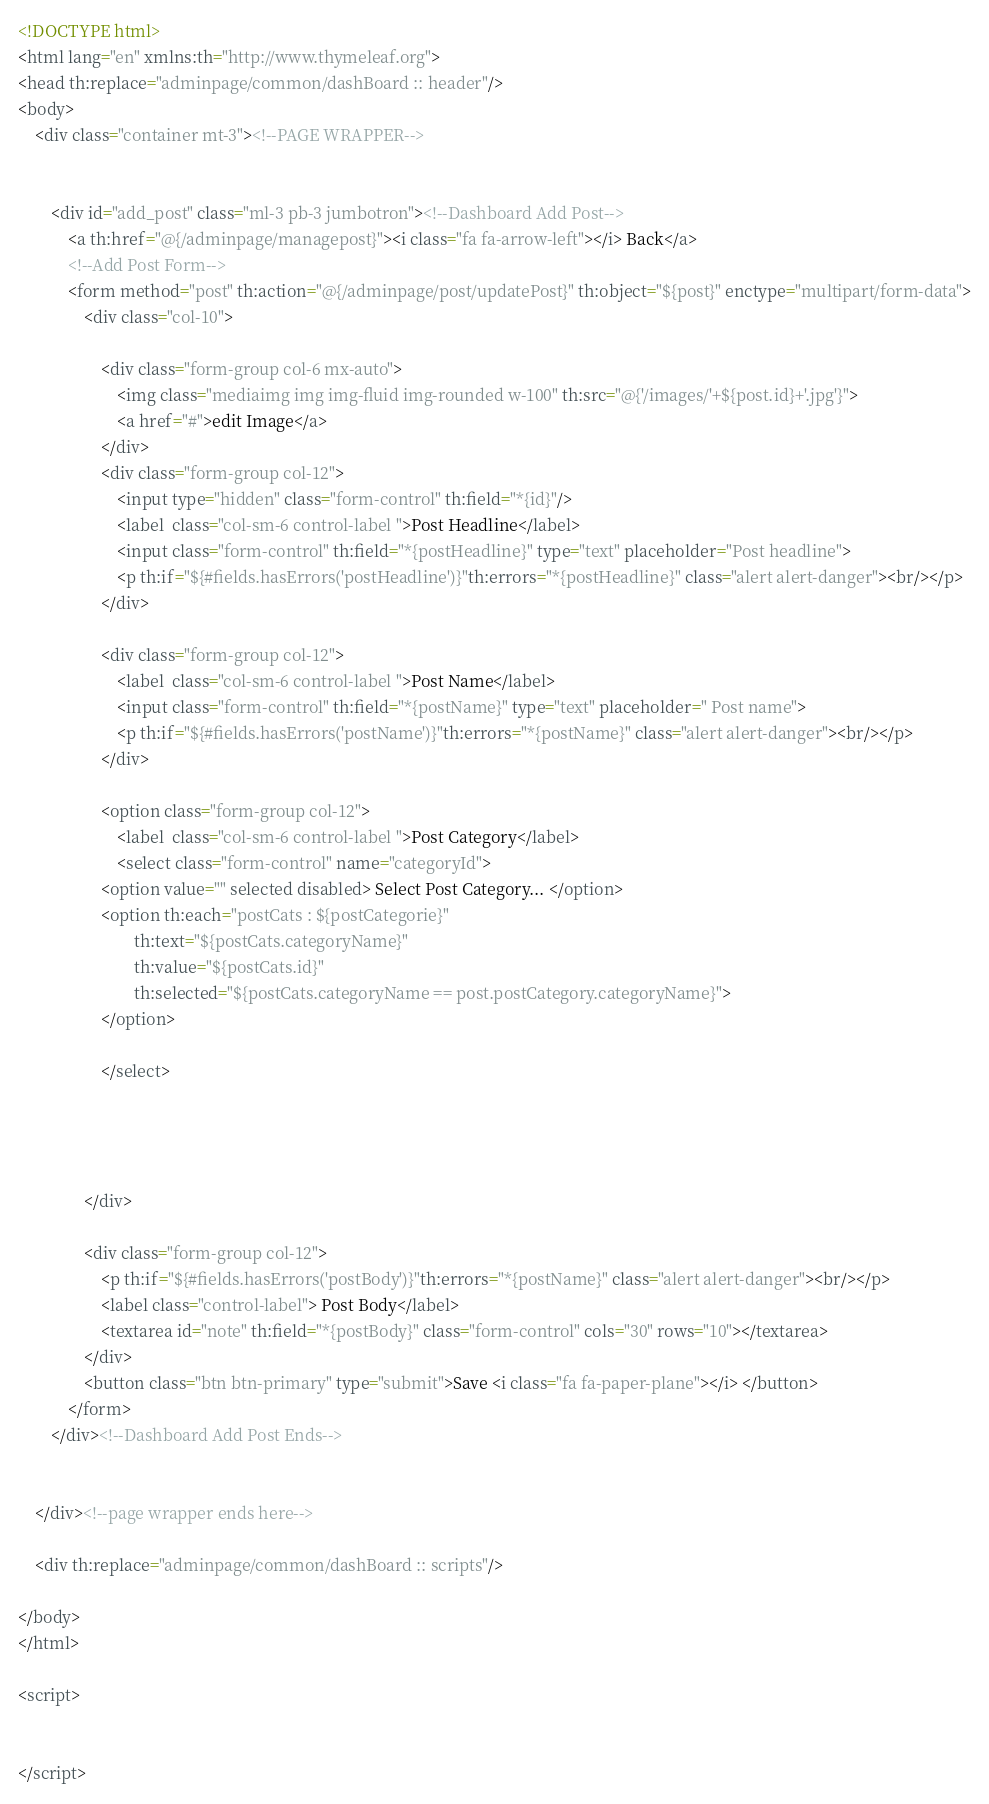Convert code to text. <code><loc_0><loc_0><loc_500><loc_500><_HTML_>
<!DOCTYPE html>
<html lang="en" xmlns:th="http://www.thymeleaf.org">
<head th:replace="adminpage/common/dashBoard :: header"/>
<body>
    <div class="container mt-3"><!--PAGE WRAPPER-->


        <div id="add_post" class="ml-3 pb-3 jumbotron"><!--Dashboard Add Post-->
            <a th:href="@{/adminpage/managepost}"><i class="fa fa-arrow-left"></i> Back</a>
            <!--Add Post Form-->
            <form method="post" th:action="@{/adminpage/post/updatePost}" th:object="${post}" enctype="multipart/form-data">
                <div class="col-10">

                    <div class="form-group col-6 mx-auto">
                        <img class="mediaimg img img-fluid img-rounded w-100" th:src="@{'/images/'+${post.id}+'.jpg'}">
                        <a href="#">edit Image</a>
                    </div>
                    <div class="form-group col-12">
                        <input type="hidden" class="form-control" th:field="*{id}"/>
                        <label  class="col-sm-6 control-label ">Post Headline</label>
                        <input class="form-control" th:field="*{postHeadline}" type="text" placeholder="Post headline">
                        <p th:if="${#fields.hasErrors('postHeadline')}"th:errors="*{postHeadline}" class="alert alert-danger"><br/></p>
                    </div>

                    <div class="form-group col-12">
                        <label  class="col-sm-6 control-label ">Post Name</label>
                        <input class="form-control" th:field="*{postName}" type="text" placeholder=" Post name">
                        <p th:if="${#fields.hasErrors('postName')}"th:errors="*{postName}" class="alert alert-danger"><br/></p>
                    </div>

                    <option class="form-group col-12">
                        <label  class="col-sm-6 control-label ">Post Category</label>
                        <select class="form-control" name="categoryId">
                    <option value="" selected disabled> Select Post Category... </option>
                    <option th:each="postCats : ${postCategorie}"
                            th:text="${postCats.categoryName}"
                            th:value="${postCats.id}"
                            th:selected="${postCats.categoryName == post.postCategory.categoryName}">
                    </option>

                    </select>




                </div>

                <div class="form-group col-12">
                    <p th:if="${#fields.hasErrors('postBody')}"th:errors="*{postName}" class="alert alert-danger"><br/></p>
                    <label class="control-label"> Post Body</label>
                    <textarea id="note" th:field="*{postBody}" class="form-control" cols="30" rows="10"></textarea>
                </div>
                <button class="btn btn-primary" type="submit">Save <i class="fa fa-paper-plane"></i> </button>
            </form>
        </div><!--Dashboard Add Post Ends-->

        
    </div><!--page wrapper ends here-->

    <div th:replace="adminpage/common/dashBoard :: scripts"/>

</body>
</html>

<script>


</script></code> 